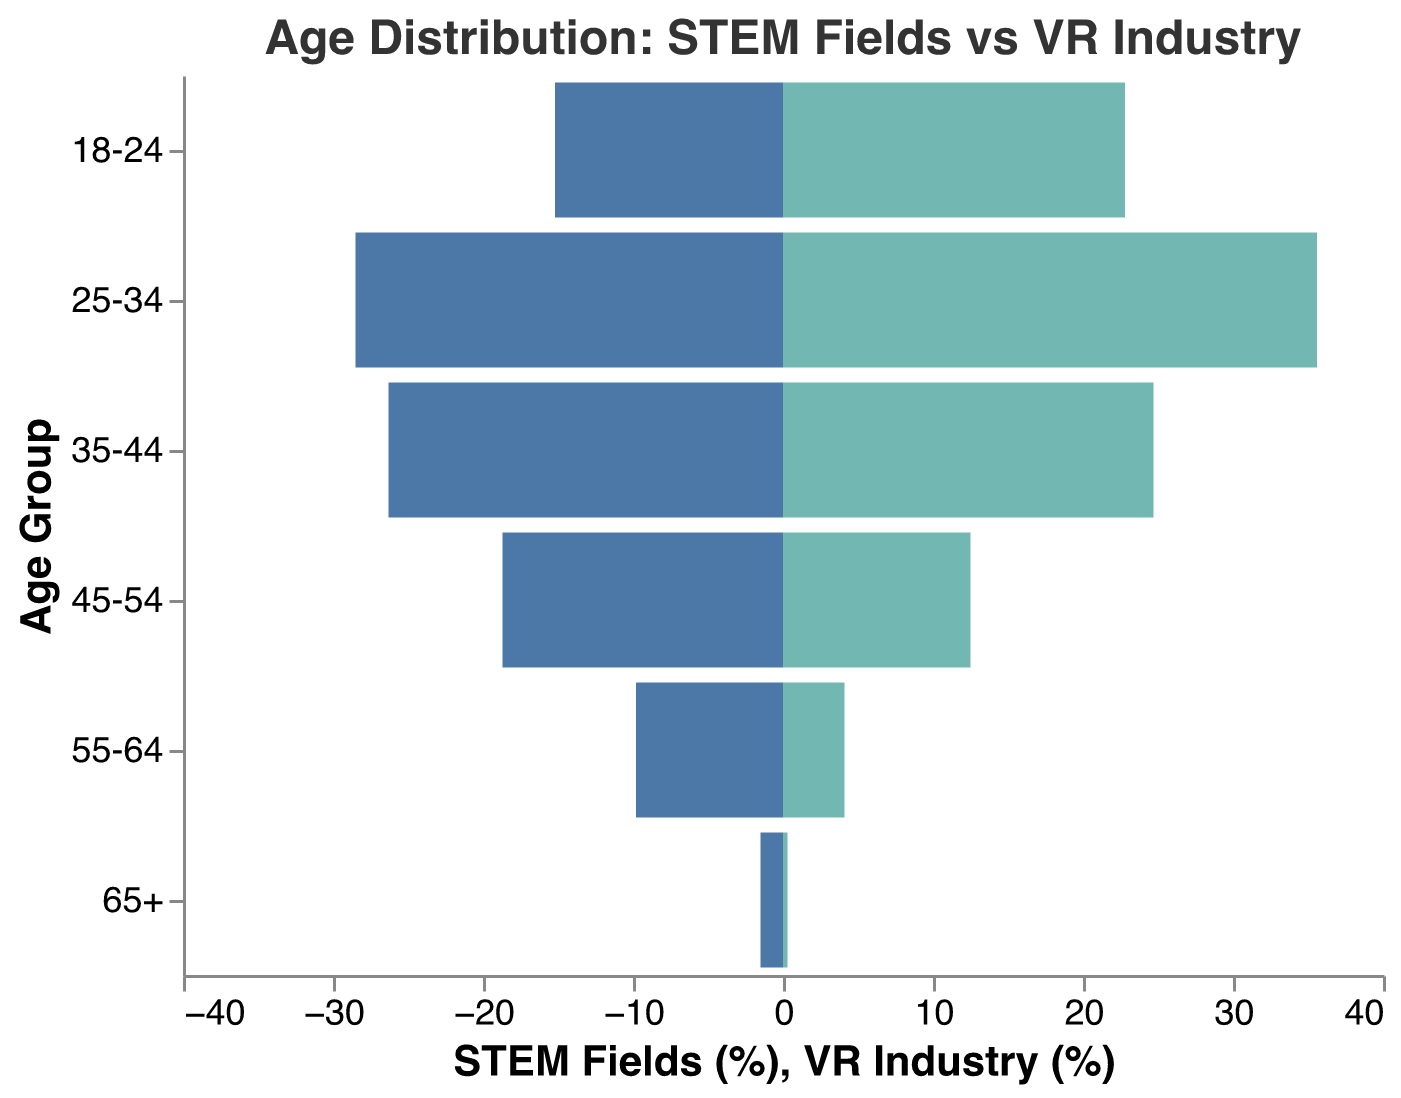What is the title of the figure? The title of the figure is located at the top and provides a brief description of what is being visualized.
Answer: Age Distribution: STEM Fields vs VR Industry What age group has the highest percentage in the VR Industry? By looking at the bar lengths for the VR Industry, we can see which bar extends the farthest to the right.
Answer: 25-34 Which age group has the smallest percentage in the STEM fields? By looking at the lengths of the negative bars for STEM Fields, we identify the shortest bar.
Answer: 65+ How does the percentage of STEM professionals aged 18-24 compare to VR industry professionals in the same age group? By comparing the lengths of the bars for the 18-24 age group, we can see which one is longer.
Answer: VR Industry professionals are higher What is the combined percentage of STEM professionals in the age groups 25-34 and 35-44? Sum the percentages for these age groups from the STEM Fields. 28.5 + 26.3.
Answer: 54.8% Is there any age group where VR industry professionals are fewer than 1%? By checking the lengths of bars for less than 1% in the VR Industry, we can identify it.
Answer: 65+ In which age group is there the largest absolute difference in percentage between STEM fields and VR industry professionals? Calculate the absolute difference for each age group and identify the largest one. For example: 35.6 - 28.5, 26.3 - 24.7, etc.
Answer: 55-64 What is the average percentage of VR industry professionals aged 45-54 and 55-64? Add the percentages for these age groups from VR Industry and divide by 2. (12.5 + 4.1) / 2.
Answer: 8.3% How many age groups have a higher percentage of VR industry professionals compared to STEM fields? Compare each age group and count where VR Industry percentage > STEM Fields percentage.
Answer: 2 